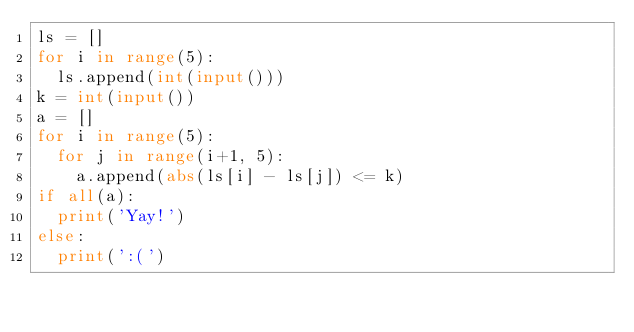Convert code to text. <code><loc_0><loc_0><loc_500><loc_500><_Python_>ls = []
for i in range(5):
  ls.append(int(input()))
k = int(input())
a = []
for i in range(5):
  for j in range(i+1, 5):
    a.append(abs(ls[i] - ls[j]) <= k)
if all(a):
  print('Yay!')
else:
  print(':(')
</code> 